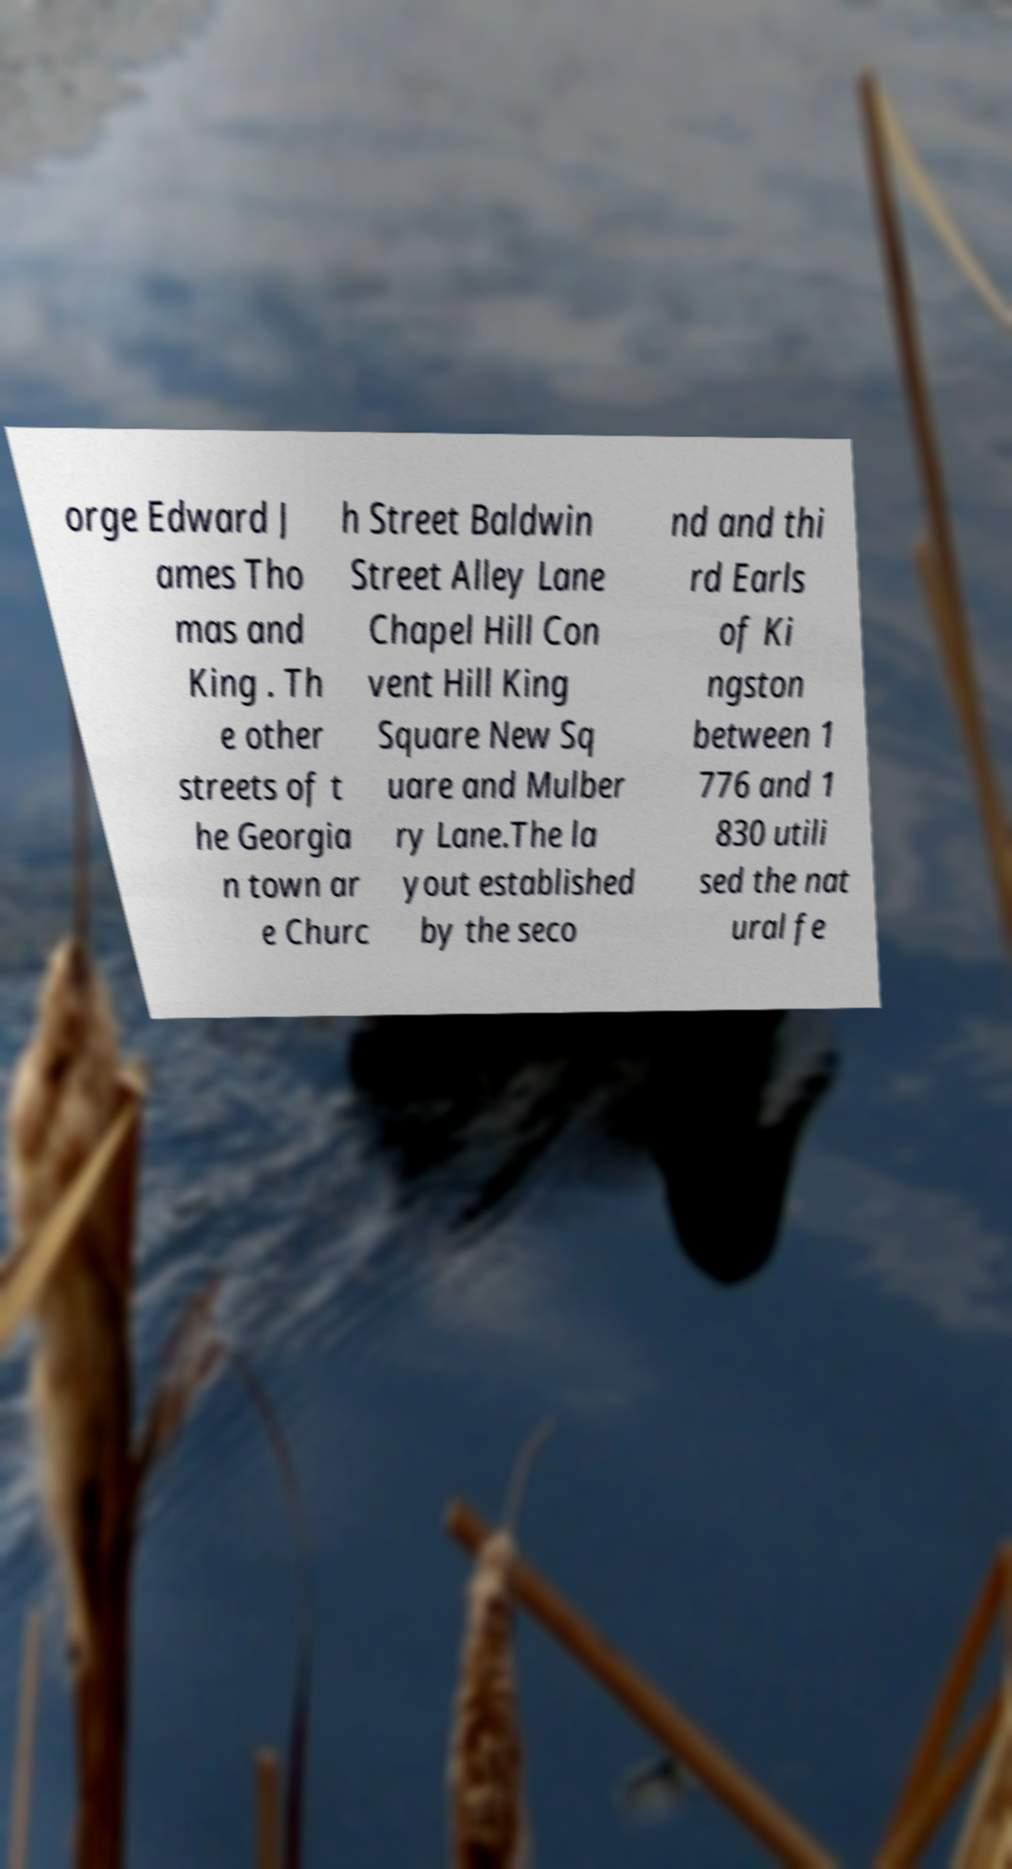For documentation purposes, I need the text within this image transcribed. Could you provide that? orge Edward J ames Tho mas and King . Th e other streets of t he Georgia n town ar e Churc h Street Baldwin Street Alley Lane Chapel Hill Con vent Hill King Square New Sq uare and Mulber ry Lane.The la yout established by the seco nd and thi rd Earls of Ki ngston between 1 776 and 1 830 utili sed the nat ural fe 